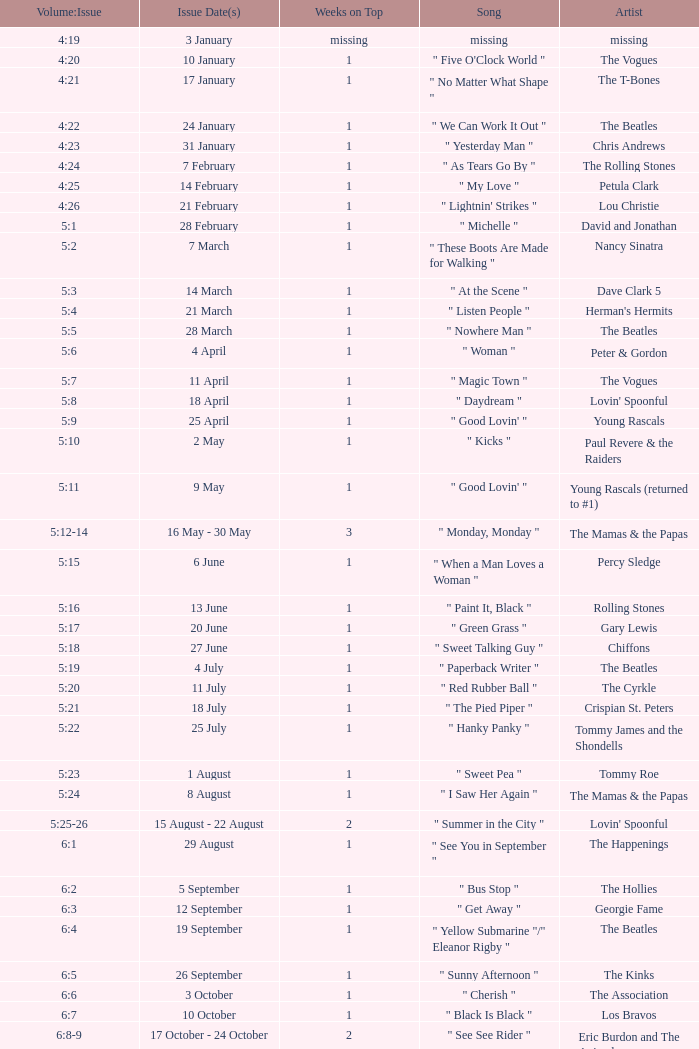Would you be able to parse every entry in this table? {'header': ['Volume:Issue', 'Issue Date(s)', 'Weeks on Top', 'Song', 'Artist'], 'rows': [['4:19', '3 January', 'missing', 'missing', 'missing'], ['4:20', '10 January', '1', '" Five O\'Clock World "', 'The Vogues'], ['4:21', '17 January', '1', '" No Matter What Shape "', 'The T-Bones'], ['4:22', '24 January', '1', '" We Can Work It Out "', 'The Beatles'], ['4:23', '31 January', '1', '" Yesterday Man "', 'Chris Andrews'], ['4:24', '7 February', '1', '" As Tears Go By "', 'The Rolling Stones'], ['4:25', '14 February', '1', '" My Love "', 'Petula Clark'], ['4:26', '21 February', '1', '" Lightnin\' Strikes "', 'Lou Christie'], ['5:1', '28 February', '1', '" Michelle "', 'David and Jonathan'], ['5:2', '7 March', '1', '" These Boots Are Made for Walking "', 'Nancy Sinatra'], ['5:3', '14 March', '1', '" At the Scene "', 'Dave Clark 5'], ['5:4', '21 March', '1', '" Listen People "', "Herman's Hermits"], ['5:5', '28 March', '1', '" Nowhere Man "', 'The Beatles'], ['5:6', '4 April', '1', '" Woman "', 'Peter & Gordon'], ['5:7', '11 April', '1', '" Magic Town "', 'The Vogues'], ['5:8', '18 April', '1', '" Daydream "', "Lovin' Spoonful"], ['5:9', '25 April', '1', '" Good Lovin\' "', 'Young Rascals'], ['5:10', '2 May', '1', '" Kicks "', 'Paul Revere & the Raiders'], ['5:11', '9 May', '1', '" Good Lovin\' "', 'Young Rascals (returned to #1)'], ['5:12-14', '16 May - 30 May', '3', '" Monday, Monday "', 'The Mamas & the Papas'], ['5:15', '6 June', '1', '" When a Man Loves a Woman "', 'Percy Sledge'], ['5:16', '13 June', '1', '" Paint It, Black "', 'Rolling Stones'], ['5:17', '20 June', '1', '" Green Grass "', 'Gary Lewis'], ['5:18', '27 June', '1', '" Sweet Talking Guy "', 'Chiffons'], ['5:19', '4 July', '1', '" Paperback Writer "', 'The Beatles'], ['5:20', '11 July', '1', '" Red Rubber Ball "', 'The Cyrkle'], ['5:21', '18 July', '1', '" The Pied Piper "', 'Crispian St. Peters'], ['5:22', '25 July', '1', '" Hanky Panky "', 'Tommy James and the Shondells'], ['5:23', '1 August', '1', '" Sweet Pea "', 'Tommy Roe'], ['5:24', '8 August', '1', '" I Saw Her Again "', 'The Mamas & the Papas'], ['5:25-26', '15 August - 22 August', '2', '" Summer in the City "', "Lovin' Spoonful"], ['6:1', '29 August', '1', '" See You in September "', 'The Happenings'], ['6:2', '5 September', '1', '" Bus Stop "', 'The Hollies'], ['6:3', '12 September', '1', '" Get Away "', 'Georgie Fame'], ['6:4', '19 September', '1', '" Yellow Submarine "/" Eleanor Rigby "', 'The Beatles'], ['6:5', '26 September', '1', '" Sunny Afternoon "', 'The Kinks'], ['6:6', '3 October', '1', '" Cherish "', 'The Association'], ['6:7', '10 October', '1', '" Black Is Black "', 'Los Bravos'], ['6:8-9', '17 October - 24 October', '2', '" See See Rider "', 'Eric Burdon and The Animals'], ['6:10', '31 October', '1', '" 96 Tears "', 'Question Mark & the Mysterians'], ['6:11', '7 November', '1', '" Last Train to Clarksville "', 'The Monkees'], ['6:12', '14 November', '1', '" Dandy "', "Herman's Hermits"], ['6:13', '21 November', '1', '" Poor Side of Town "', 'Johnny Rivers'], ['6:14-15', '28 November - 5 December', '2', '" Winchester Cathedral "', 'New Vaudeville Band'], ['6:16', '12 December', '1', '" Lady Godiva "', 'Peter & Gordon'], ['6:17', '19 December', '1', '" Stop! Stop! Stop! "', 'The Hollies'], ['6:18-19', '26 December - 2 January', '2', '" I\'m a Believer "', 'The Monkees']]} With an issue date(s) of 12 September, what is in the column for Weeks on Top? 1.0. 